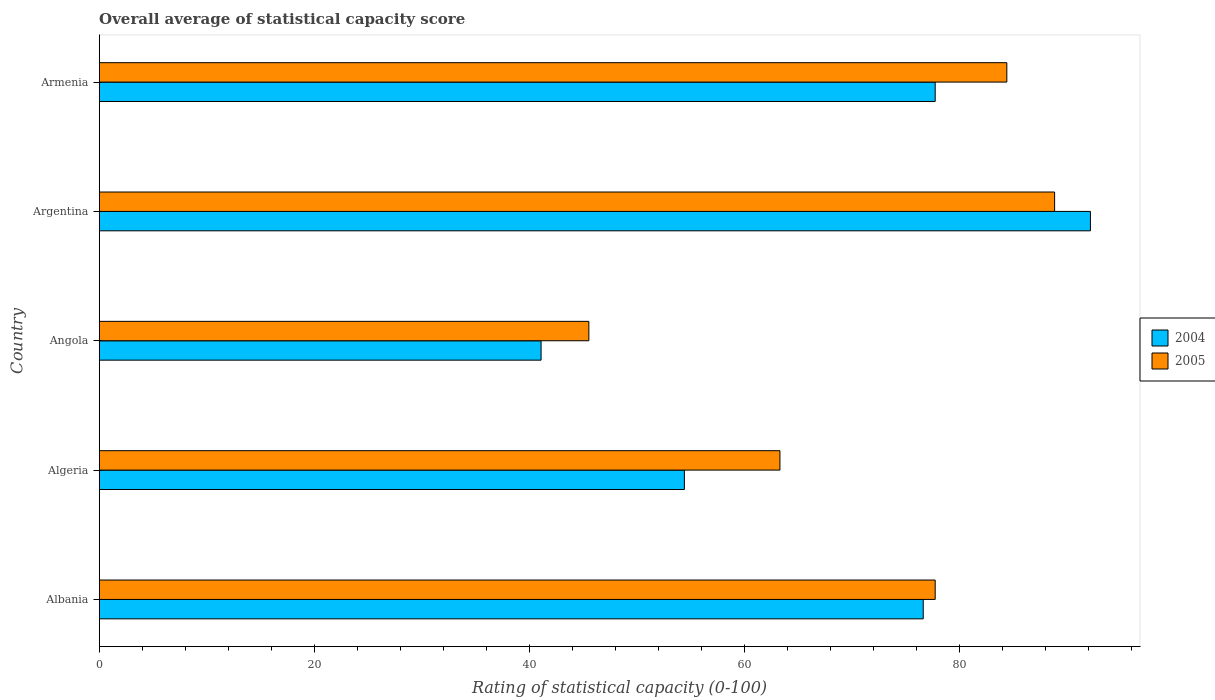How many groups of bars are there?
Give a very brief answer. 5. Are the number of bars per tick equal to the number of legend labels?
Your answer should be compact. Yes. Are the number of bars on each tick of the Y-axis equal?
Provide a short and direct response. Yes. How many bars are there on the 3rd tick from the bottom?
Offer a terse response. 2. What is the label of the 5th group of bars from the top?
Make the answer very short. Albania. What is the rating of statistical capacity in 2004 in Angola?
Make the answer very short. 41.11. Across all countries, what is the maximum rating of statistical capacity in 2004?
Provide a short and direct response. 92.22. Across all countries, what is the minimum rating of statistical capacity in 2004?
Your response must be concise. 41.11. In which country was the rating of statistical capacity in 2004 maximum?
Offer a terse response. Argentina. In which country was the rating of statistical capacity in 2005 minimum?
Your response must be concise. Angola. What is the total rating of statistical capacity in 2004 in the graph?
Offer a terse response. 342.22. What is the difference between the rating of statistical capacity in 2005 in Algeria and that in Argentina?
Offer a terse response. -25.56. What is the difference between the rating of statistical capacity in 2004 in Algeria and the rating of statistical capacity in 2005 in Albania?
Provide a short and direct response. -23.33. What is the average rating of statistical capacity in 2004 per country?
Offer a very short reply. 68.44. What is the difference between the rating of statistical capacity in 2004 and rating of statistical capacity in 2005 in Armenia?
Give a very brief answer. -6.67. In how many countries, is the rating of statistical capacity in 2005 greater than 80 ?
Your answer should be very brief. 2. What is the ratio of the rating of statistical capacity in 2005 in Albania to that in Armenia?
Make the answer very short. 0.92. Is the difference between the rating of statistical capacity in 2004 in Albania and Argentina greater than the difference between the rating of statistical capacity in 2005 in Albania and Argentina?
Give a very brief answer. No. What is the difference between the highest and the second highest rating of statistical capacity in 2004?
Keep it short and to the point. 14.44. What is the difference between the highest and the lowest rating of statistical capacity in 2005?
Provide a succinct answer. 43.33. Is the sum of the rating of statistical capacity in 2004 in Algeria and Armenia greater than the maximum rating of statistical capacity in 2005 across all countries?
Your answer should be compact. Yes. What does the 2nd bar from the top in Armenia represents?
Give a very brief answer. 2004. How many bars are there?
Ensure brevity in your answer.  10. What is the difference between two consecutive major ticks on the X-axis?
Your answer should be compact. 20. Does the graph contain any zero values?
Your response must be concise. No. Does the graph contain grids?
Make the answer very short. No. How are the legend labels stacked?
Provide a succinct answer. Vertical. What is the title of the graph?
Make the answer very short. Overall average of statistical capacity score. Does "2004" appear as one of the legend labels in the graph?
Offer a very short reply. Yes. What is the label or title of the X-axis?
Provide a short and direct response. Rating of statistical capacity (0-100). What is the Rating of statistical capacity (0-100) in 2004 in Albania?
Keep it short and to the point. 76.67. What is the Rating of statistical capacity (0-100) of 2005 in Albania?
Give a very brief answer. 77.78. What is the Rating of statistical capacity (0-100) in 2004 in Algeria?
Keep it short and to the point. 54.44. What is the Rating of statistical capacity (0-100) in 2005 in Algeria?
Keep it short and to the point. 63.33. What is the Rating of statistical capacity (0-100) in 2004 in Angola?
Your answer should be compact. 41.11. What is the Rating of statistical capacity (0-100) of 2005 in Angola?
Your answer should be compact. 45.56. What is the Rating of statistical capacity (0-100) in 2004 in Argentina?
Your answer should be compact. 92.22. What is the Rating of statistical capacity (0-100) of 2005 in Argentina?
Provide a succinct answer. 88.89. What is the Rating of statistical capacity (0-100) of 2004 in Armenia?
Provide a short and direct response. 77.78. What is the Rating of statistical capacity (0-100) in 2005 in Armenia?
Offer a very short reply. 84.44. Across all countries, what is the maximum Rating of statistical capacity (0-100) in 2004?
Make the answer very short. 92.22. Across all countries, what is the maximum Rating of statistical capacity (0-100) of 2005?
Offer a very short reply. 88.89. Across all countries, what is the minimum Rating of statistical capacity (0-100) in 2004?
Offer a very short reply. 41.11. Across all countries, what is the minimum Rating of statistical capacity (0-100) in 2005?
Your answer should be compact. 45.56. What is the total Rating of statistical capacity (0-100) in 2004 in the graph?
Your answer should be compact. 342.22. What is the total Rating of statistical capacity (0-100) in 2005 in the graph?
Keep it short and to the point. 360. What is the difference between the Rating of statistical capacity (0-100) of 2004 in Albania and that in Algeria?
Your response must be concise. 22.22. What is the difference between the Rating of statistical capacity (0-100) in 2005 in Albania and that in Algeria?
Your answer should be very brief. 14.44. What is the difference between the Rating of statistical capacity (0-100) in 2004 in Albania and that in Angola?
Offer a terse response. 35.56. What is the difference between the Rating of statistical capacity (0-100) in 2005 in Albania and that in Angola?
Give a very brief answer. 32.22. What is the difference between the Rating of statistical capacity (0-100) of 2004 in Albania and that in Argentina?
Offer a very short reply. -15.56. What is the difference between the Rating of statistical capacity (0-100) in 2005 in Albania and that in Argentina?
Provide a succinct answer. -11.11. What is the difference between the Rating of statistical capacity (0-100) of 2004 in Albania and that in Armenia?
Your answer should be very brief. -1.11. What is the difference between the Rating of statistical capacity (0-100) in 2005 in Albania and that in Armenia?
Your answer should be very brief. -6.67. What is the difference between the Rating of statistical capacity (0-100) of 2004 in Algeria and that in Angola?
Keep it short and to the point. 13.33. What is the difference between the Rating of statistical capacity (0-100) in 2005 in Algeria and that in Angola?
Give a very brief answer. 17.78. What is the difference between the Rating of statistical capacity (0-100) of 2004 in Algeria and that in Argentina?
Make the answer very short. -37.78. What is the difference between the Rating of statistical capacity (0-100) of 2005 in Algeria and that in Argentina?
Keep it short and to the point. -25.56. What is the difference between the Rating of statistical capacity (0-100) in 2004 in Algeria and that in Armenia?
Offer a terse response. -23.33. What is the difference between the Rating of statistical capacity (0-100) in 2005 in Algeria and that in Armenia?
Offer a very short reply. -21.11. What is the difference between the Rating of statistical capacity (0-100) in 2004 in Angola and that in Argentina?
Offer a very short reply. -51.11. What is the difference between the Rating of statistical capacity (0-100) in 2005 in Angola and that in Argentina?
Ensure brevity in your answer.  -43.33. What is the difference between the Rating of statistical capacity (0-100) of 2004 in Angola and that in Armenia?
Ensure brevity in your answer.  -36.67. What is the difference between the Rating of statistical capacity (0-100) in 2005 in Angola and that in Armenia?
Make the answer very short. -38.89. What is the difference between the Rating of statistical capacity (0-100) of 2004 in Argentina and that in Armenia?
Provide a succinct answer. 14.44. What is the difference between the Rating of statistical capacity (0-100) in 2005 in Argentina and that in Armenia?
Provide a succinct answer. 4.44. What is the difference between the Rating of statistical capacity (0-100) in 2004 in Albania and the Rating of statistical capacity (0-100) in 2005 in Algeria?
Provide a short and direct response. 13.33. What is the difference between the Rating of statistical capacity (0-100) in 2004 in Albania and the Rating of statistical capacity (0-100) in 2005 in Angola?
Ensure brevity in your answer.  31.11. What is the difference between the Rating of statistical capacity (0-100) in 2004 in Albania and the Rating of statistical capacity (0-100) in 2005 in Argentina?
Ensure brevity in your answer.  -12.22. What is the difference between the Rating of statistical capacity (0-100) in 2004 in Albania and the Rating of statistical capacity (0-100) in 2005 in Armenia?
Provide a succinct answer. -7.78. What is the difference between the Rating of statistical capacity (0-100) in 2004 in Algeria and the Rating of statistical capacity (0-100) in 2005 in Angola?
Give a very brief answer. 8.89. What is the difference between the Rating of statistical capacity (0-100) in 2004 in Algeria and the Rating of statistical capacity (0-100) in 2005 in Argentina?
Your answer should be compact. -34.44. What is the difference between the Rating of statistical capacity (0-100) in 2004 in Angola and the Rating of statistical capacity (0-100) in 2005 in Argentina?
Provide a succinct answer. -47.78. What is the difference between the Rating of statistical capacity (0-100) in 2004 in Angola and the Rating of statistical capacity (0-100) in 2005 in Armenia?
Offer a terse response. -43.33. What is the difference between the Rating of statistical capacity (0-100) of 2004 in Argentina and the Rating of statistical capacity (0-100) of 2005 in Armenia?
Ensure brevity in your answer.  7.78. What is the average Rating of statistical capacity (0-100) in 2004 per country?
Keep it short and to the point. 68.44. What is the difference between the Rating of statistical capacity (0-100) in 2004 and Rating of statistical capacity (0-100) in 2005 in Albania?
Offer a terse response. -1.11. What is the difference between the Rating of statistical capacity (0-100) of 2004 and Rating of statistical capacity (0-100) of 2005 in Algeria?
Your answer should be very brief. -8.89. What is the difference between the Rating of statistical capacity (0-100) of 2004 and Rating of statistical capacity (0-100) of 2005 in Angola?
Keep it short and to the point. -4.44. What is the difference between the Rating of statistical capacity (0-100) of 2004 and Rating of statistical capacity (0-100) of 2005 in Armenia?
Make the answer very short. -6.67. What is the ratio of the Rating of statistical capacity (0-100) of 2004 in Albania to that in Algeria?
Provide a succinct answer. 1.41. What is the ratio of the Rating of statistical capacity (0-100) in 2005 in Albania to that in Algeria?
Provide a succinct answer. 1.23. What is the ratio of the Rating of statistical capacity (0-100) of 2004 in Albania to that in Angola?
Provide a short and direct response. 1.86. What is the ratio of the Rating of statistical capacity (0-100) in 2005 in Albania to that in Angola?
Your answer should be compact. 1.71. What is the ratio of the Rating of statistical capacity (0-100) in 2004 in Albania to that in Argentina?
Ensure brevity in your answer.  0.83. What is the ratio of the Rating of statistical capacity (0-100) in 2004 in Albania to that in Armenia?
Offer a terse response. 0.99. What is the ratio of the Rating of statistical capacity (0-100) in 2005 in Albania to that in Armenia?
Make the answer very short. 0.92. What is the ratio of the Rating of statistical capacity (0-100) of 2004 in Algeria to that in Angola?
Make the answer very short. 1.32. What is the ratio of the Rating of statistical capacity (0-100) of 2005 in Algeria to that in Angola?
Your answer should be compact. 1.39. What is the ratio of the Rating of statistical capacity (0-100) in 2004 in Algeria to that in Argentina?
Offer a terse response. 0.59. What is the ratio of the Rating of statistical capacity (0-100) of 2005 in Algeria to that in Argentina?
Provide a succinct answer. 0.71. What is the ratio of the Rating of statistical capacity (0-100) in 2004 in Algeria to that in Armenia?
Keep it short and to the point. 0.7. What is the ratio of the Rating of statistical capacity (0-100) of 2004 in Angola to that in Argentina?
Keep it short and to the point. 0.45. What is the ratio of the Rating of statistical capacity (0-100) in 2005 in Angola to that in Argentina?
Make the answer very short. 0.51. What is the ratio of the Rating of statistical capacity (0-100) in 2004 in Angola to that in Armenia?
Provide a succinct answer. 0.53. What is the ratio of the Rating of statistical capacity (0-100) in 2005 in Angola to that in Armenia?
Provide a succinct answer. 0.54. What is the ratio of the Rating of statistical capacity (0-100) in 2004 in Argentina to that in Armenia?
Keep it short and to the point. 1.19. What is the ratio of the Rating of statistical capacity (0-100) of 2005 in Argentina to that in Armenia?
Offer a very short reply. 1.05. What is the difference between the highest and the second highest Rating of statistical capacity (0-100) in 2004?
Provide a succinct answer. 14.44. What is the difference between the highest and the second highest Rating of statistical capacity (0-100) in 2005?
Your response must be concise. 4.44. What is the difference between the highest and the lowest Rating of statistical capacity (0-100) in 2004?
Keep it short and to the point. 51.11. What is the difference between the highest and the lowest Rating of statistical capacity (0-100) in 2005?
Provide a short and direct response. 43.33. 